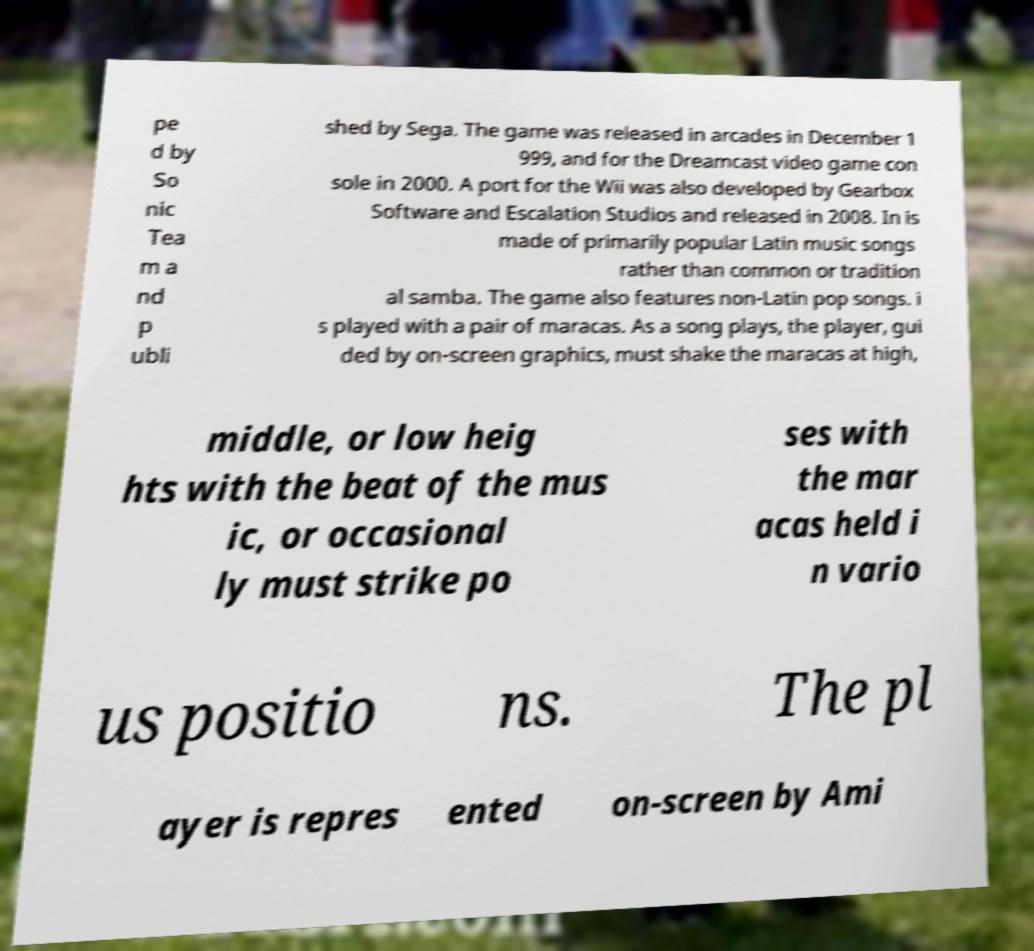I need the written content from this picture converted into text. Can you do that? pe d by So nic Tea m a nd p ubli shed by Sega. The game was released in arcades in December 1 999, and for the Dreamcast video game con sole in 2000. A port for the Wii was also developed by Gearbox Software and Escalation Studios and released in 2008. In is made of primarily popular Latin music songs rather than common or tradition al samba. The game also features non-Latin pop songs. i s played with a pair of maracas. As a song plays, the player, gui ded by on-screen graphics, must shake the maracas at high, middle, or low heig hts with the beat of the mus ic, or occasional ly must strike po ses with the mar acas held i n vario us positio ns. The pl ayer is repres ented on-screen by Ami 